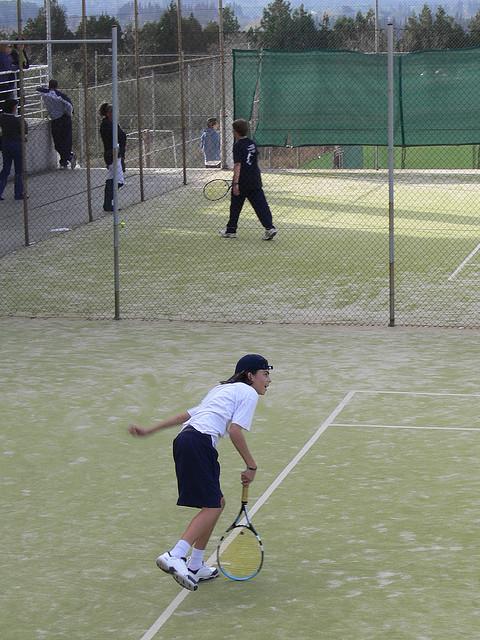What color is the court?
Keep it brief. Green. How many rackets are shown?
Answer briefly. 2. Where is the chain fence?
Answer briefly. Between courts. Is the ball in the air?
Give a very brief answer. No. 